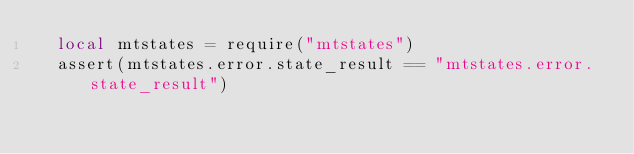Convert code to text. <code><loc_0><loc_0><loc_500><loc_500><_Lua_>  local mtstates = require("mtstates")
  assert(mtstates.error.state_result == "mtstates.error.state_result")</code> 